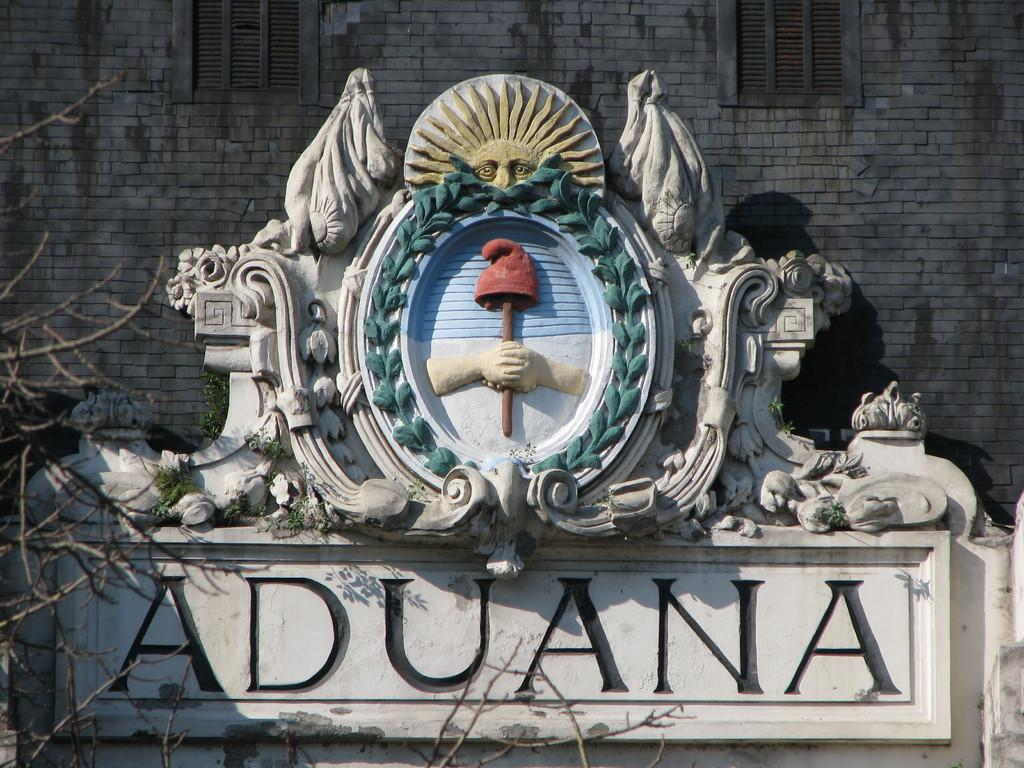What is the main subject in the image? There is a statue in the image. What is written or depicted under the statue? There is text under the statue. What type of vegetation can be seen in the image? There are branches of a tree and plants in the image. What type of structure is visible in the image? There is a wall in the image. What architectural feature can be seen in the wall? There are windows in the wall. What type of whip is being used to transport people on a voyage in the image? There is no whip, transportation, or voyage depicted in the image; it features a statue with text, plants, and a wall with windows. 